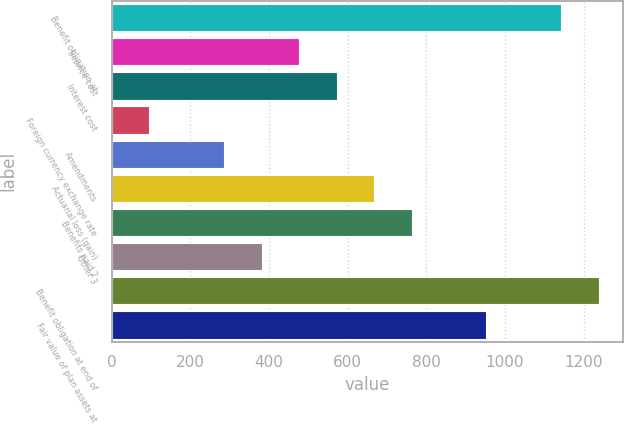<chart> <loc_0><loc_0><loc_500><loc_500><bar_chart><fcel>Benefit obligation at<fcel>Service cost<fcel>Interest cost<fcel>Foreign currency exchange rate<fcel>Amendments<fcel>Actuarial loss (gain)<fcel>Benefits paid 2<fcel>Other 3<fcel>Benefit obligation at end of<fcel>Fair value of plan assets at<nl><fcel>1143.4<fcel>477<fcel>572.2<fcel>96.2<fcel>286.6<fcel>667.4<fcel>762.6<fcel>381.8<fcel>1238.6<fcel>953<nl></chart> 